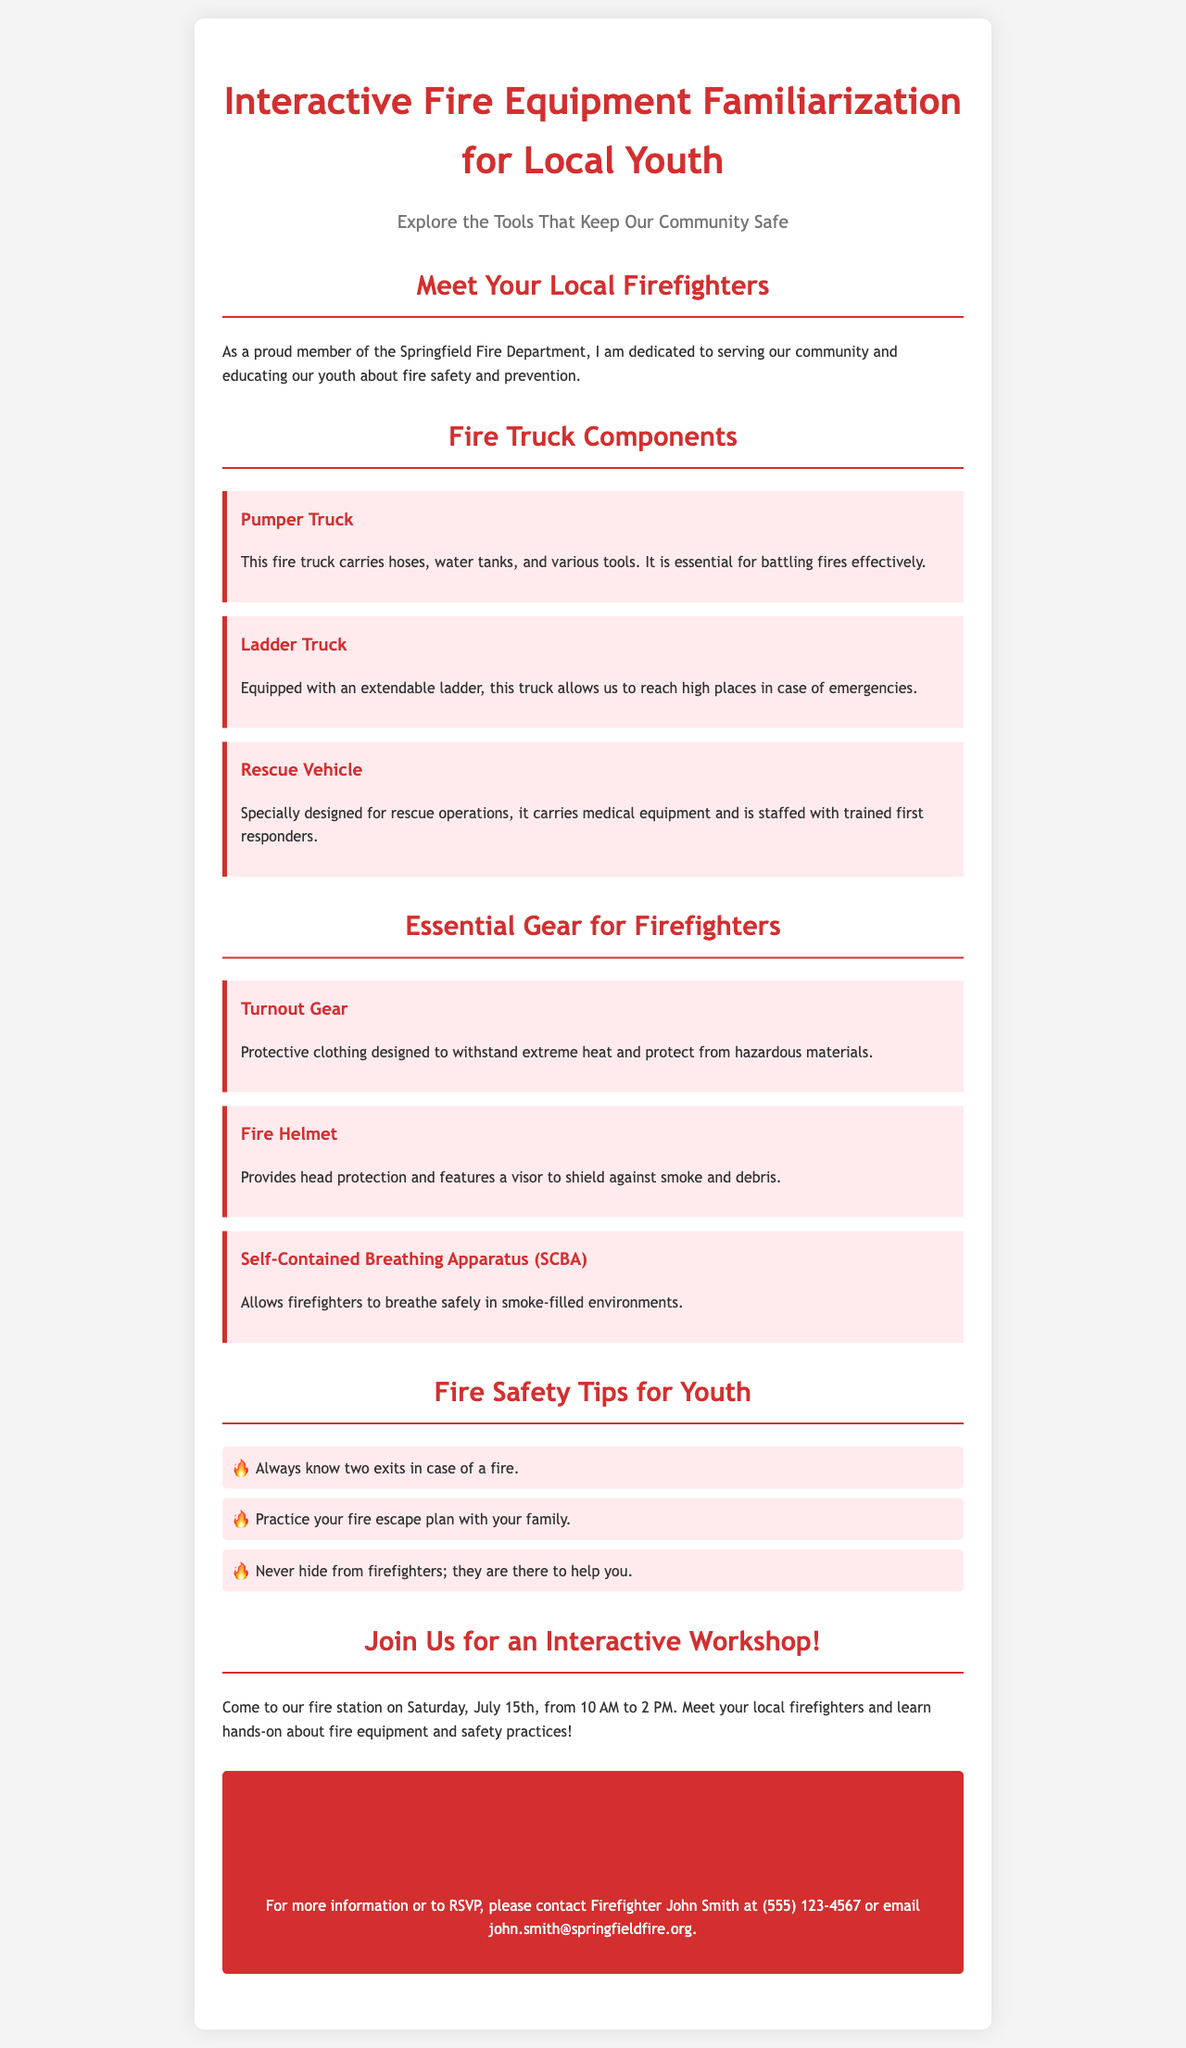What is the title of the brochure? The title is prominently displayed at the top of the brochure and is "Interactive Fire Equipment Familiarization for Local Youth."
Answer: Interactive Fire Equipment Familiarization for Local Youth Who is the author of the brochure? The author introduces themselves as a member of the Springfield Fire Department in the introduction section.
Answer: Firefighter John Smith What date is the interactive workshop scheduled for? The date of the workshop is given in the section inviting attendees to join, stating it occurs on July 15th.
Answer: July 15th What protective clothing is listed as essential gear for firefighters? "Turnout Gear" is one of the types of essential gear mentioned in the brochure.
Answer: Turnout Gear What is the purpose of the Rescue Vehicle? The Rescue Vehicle is designed for specific functions detailed in the brochure, which includes carrying medical equipment.
Answer: Rescue operations How many safety tips are provided for youth in the document? The number of bullet points listed under "Fire Safety Tips for Youth" indicates there are three specific tips given.
Answer: Three What is the color of the contact section’s background? The design of the brochure specifies that the contact section has a particular background color, which is red.
Answer: Red Who should be contacted for more information? The brochure specifies that Firefighter John Smith is the primary contact person for additional information.
Answer: Firefighter John Smith What time does the interactive workshop start? The time is mentioned in the workshop details, indicating when it begins.
Answer: 10 AM 